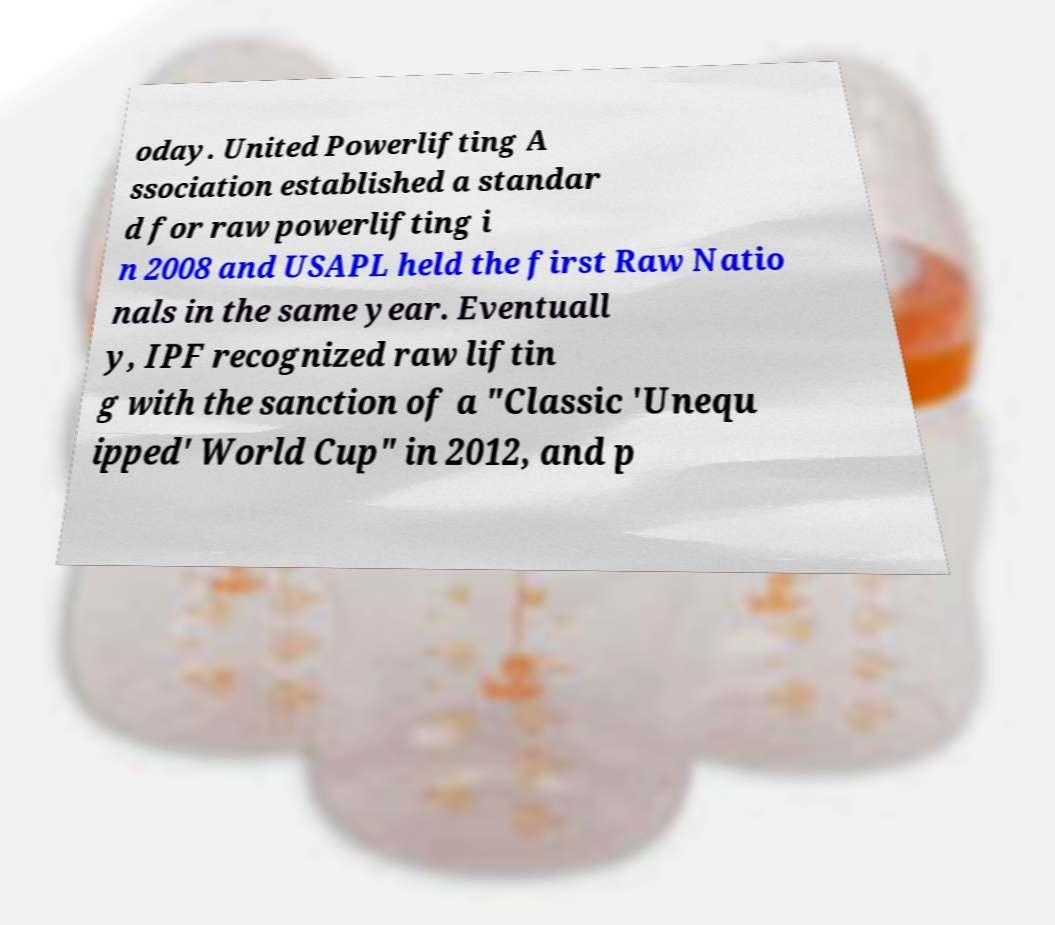There's text embedded in this image that I need extracted. Can you transcribe it verbatim? oday. United Powerlifting A ssociation established a standar d for raw powerlifting i n 2008 and USAPL held the first Raw Natio nals in the same year. Eventuall y, IPF recognized raw liftin g with the sanction of a "Classic 'Unequ ipped' World Cup" in 2012, and p 